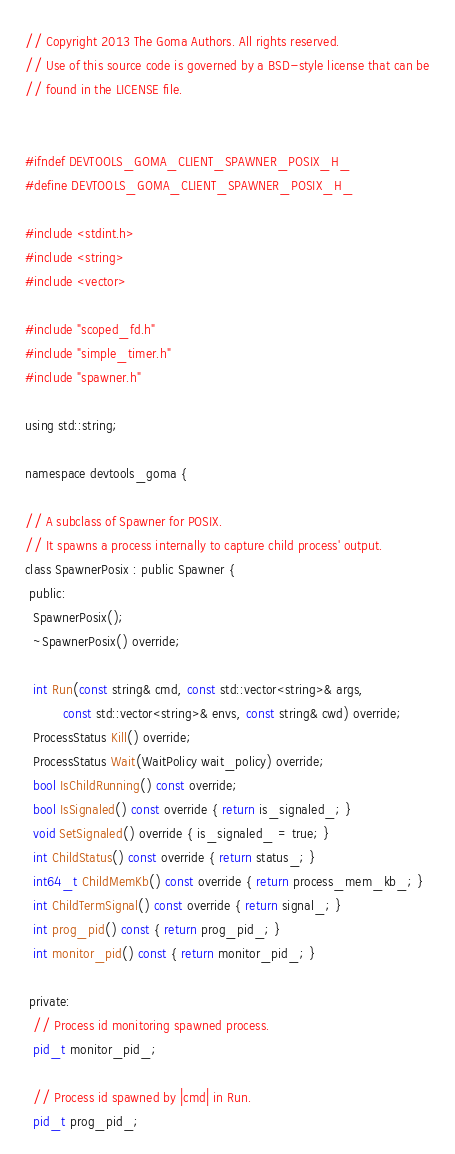<code> <loc_0><loc_0><loc_500><loc_500><_C_>// Copyright 2013 The Goma Authors. All rights reserved.
// Use of this source code is governed by a BSD-style license that can be
// found in the LICENSE file.


#ifndef DEVTOOLS_GOMA_CLIENT_SPAWNER_POSIX_H_
#define DEVTOOLS_GOMA_CLIENT_SPAWNER_POSIX_H_

#include <stdint.h>
#include <string>
#include <vector>

#include "scoped_fd.h"
#include "simple_timer.h"
#include "spawner.h"

using std::string;

namespace devtools_goma {

// A subclass of Spawner for POSIX.
// It spawns a process internally to capture child process' output.
class SpawnerPosix : public Spawner {
 public:
  SpawnerPosix();
  ~SpawnerPosix() override;

  int Run(const string& cmd, const std::vector<string>& args,
          const std::vector<string>& envs, const string& cwd) override;
  ProcessStatus Kill() override;
  ProcessStatus Wait(WaitPolicy wait_policy) override;
  bool IsChildRunning() const override;
  bool IsSignaled() const override { return is_signaled_; }
  void SetSignaled() override { is_signaled_ = true; }
  int ChildStatus() const override { return status_; }
  int64_t ChildMemKb() const override { return process_mem_kb_; }
  int ChildTermSignal() const override { return signal_; }
  int prog_pid() const { return prog_pid_; }
  int monitor_pid() const { return monitor_pid_; }

 private:
  // Process id monitoring spawned process.
  pid_t monitor_pid_;

  // Process id spawned by |cmd| in Run.
  pid_t prog_pid_;
</code> 